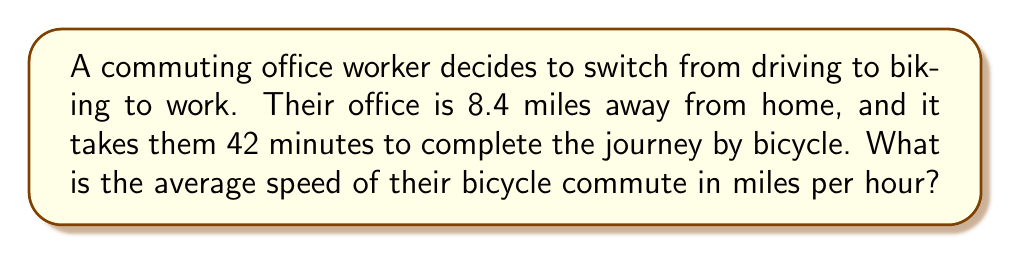What is the answer to this math problem? To solve this problem, we need to use the relationship between distance, time, and speed. The formula for average speed is:

$$\text{Average Speed} = \frac{\text{Distance}}{\text{Time}}$$

We are given the following information:
- Distance: 8.4 miles
- Time: 42 minutes

However, we need to convert the time to hours for our calculation:

$$42 \text{ minutes} = \frac{42}{60} \text{ hours} = 0.7 \text{ hours}$$

Now we can plug these values into our formula:

$$\text{Average Speed} = \frac{8.4 \text{ miles}}{0.7 \text{ hours}}$$

Performing the division:

$$\text{Average Speed} = 12 \text{ miles per hour}$$

Therefore, the average speed of the bicycle commute is 12 miles per hour.
Answer: $12 \text{ miles per hour}$ 